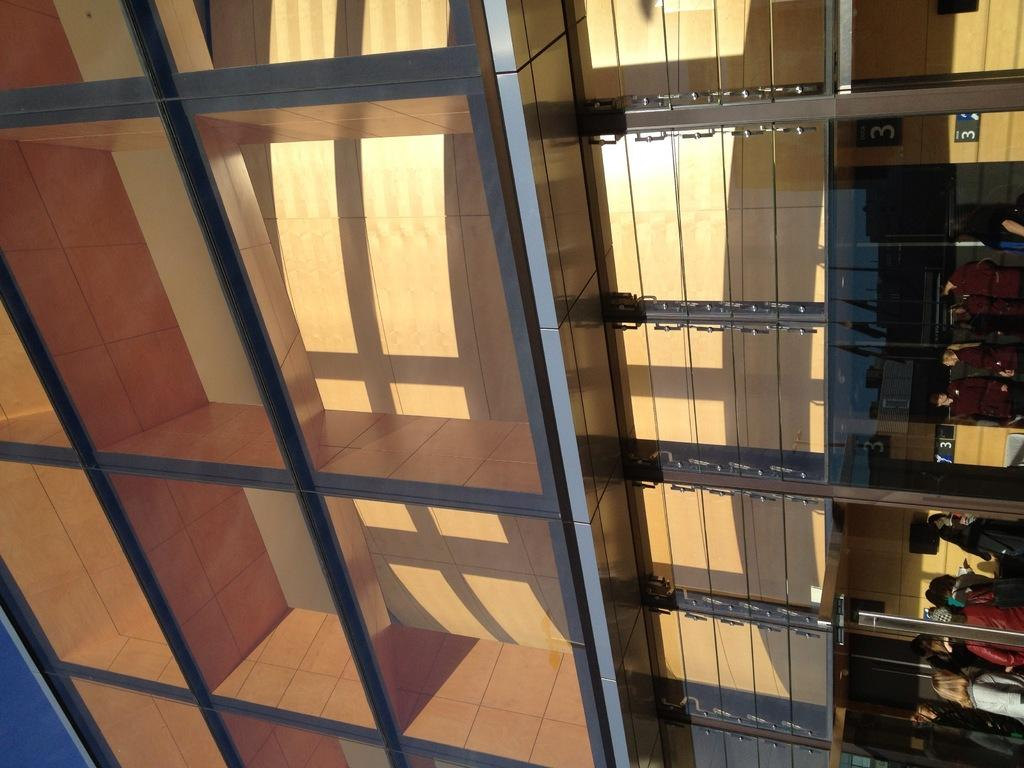<image>
Share a concise interpretation of the image provided. A series of cubbies and shadows there is a 3 in the upper right corner. 